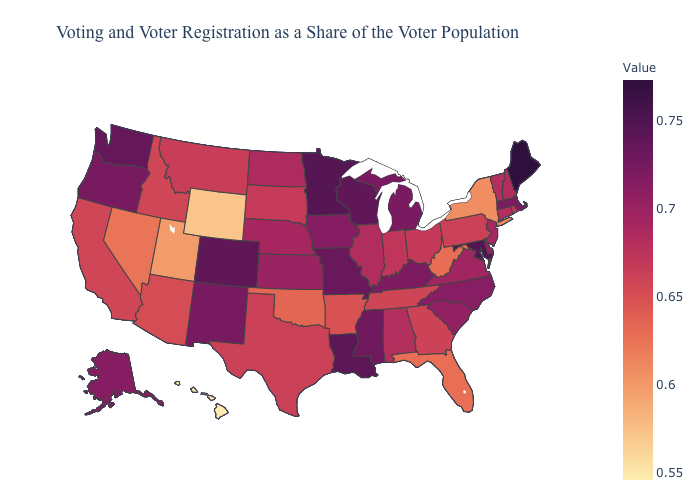Which states have the lowest value in the South?
Write a very short answer. Florida. Which states have the lowest value in the MidWest?
Concise answer only. South Dakota. Among the states that border Arizona , which have the highest value?
Short answer required. Colorado. Does Connecticut have a higher value than Arkansas?
Short answer required. Yes. Does Michigan have a lower value than Nebraska?
Write a very short answer. No. 